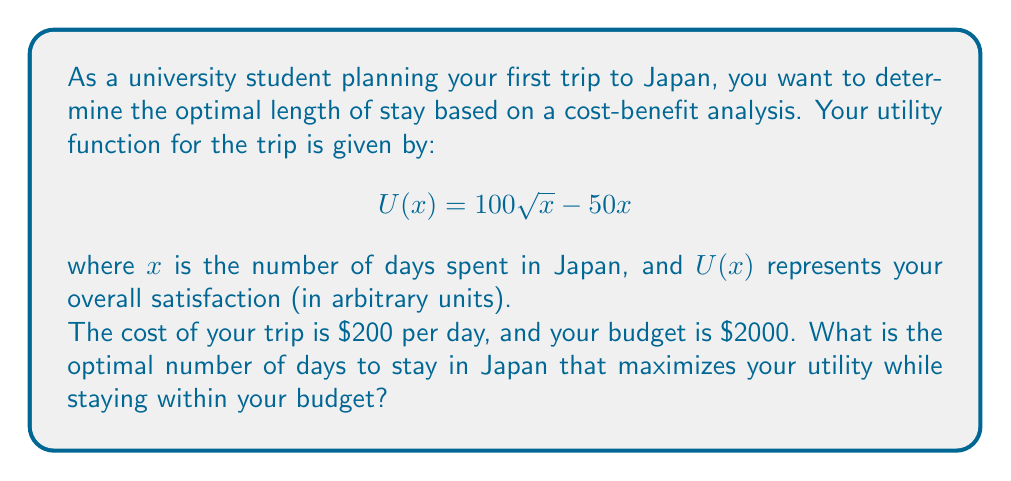What is the answer to this math problem? To solve this problem, we'll follow these steps:

1. Find the maximum of the utility function (ignoring the budget constraint).
2. Check if the maximum point satisfies the budget constraint.
3. If not, find the optimal point within the budget constraint.

Step 1: Find the maximum of the utility function

To find the maximum of $U(x) = 100\sqrt{x} - 50x$, we differentiate and set it to zero:

$$\frac{dU}{dx} = \frac{50}{\sqrt{x}} - 50 = 0$$

Solving this equation:

$$\frac{50}{\sqrt{x}} = 50$$
$$\sqrt{x} = 1$$
$$x = 1$$

The second derivative is negative, confirming this is a maximum.

Step 2: Check the budget constraint

The budget constraint is:
$$200x \leq 2000$$
$$x \leq 10$$

The maximum point $x = 1$ satisfies this constraint, so we need to check if there's a higher utility point within the constraint.

Step 3: Find the optimal point within the budget constraint

We can do this by evaluating the utility function at $x = 1$ and $x = 10$ (the budget limit):

For $x = 1$: $U(1) = 100\sqrt{1} - 50(1) = 50$
For $x = 10$: $U(10) = 100\sqrt{10} - 50(10) = 316.23 - 500 = -183.77$

The utility at $x = 1$ is higher, so this is our optimal solution.
Answer: The optimal length of stay in Japan is 1 day, which maximizes the utility function while staying within the budget constraint. 